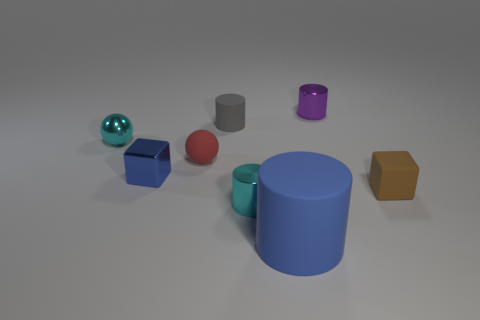Do the brown block and the cyan metal cylinder have the same size?
Keep it short and to the point. Yes. Are there any tiny gray rubber objects in front of the tiny cube that is on the right side of the red matte object?
Provide a short and direct response. No. There is a cube that is the same color as the large rubber cylinder; what size is it?
Provide a succinct answer. Small. What is the shape of the cyan shiny object left of the tiny cyan cylinder?
Ensure brevity in your answer.  Sphere. There is a tiny cyan shiny object behind the small thing that is on the right side of the tiny purple shiny object; what number of metallic spheres are behind it?
Offer a very short reply. 0. Do the rubber block and the cyan thing in front of the cyan metallic ball have the same size?
Provide a short and direct response. Yes. What is the size of the metal object that is in front of the cube in front of the shiny block?
Your answer should be very brief. Small. How many small purple things are made of the same material as the small blue object?
Offer a terse response. 1. Are any yellow cylinders visible?
Ensure brevity in your answer.  No. There is a matte cube that is right of the rubber sphere; how big is it?
Offer a terse response. Small. 